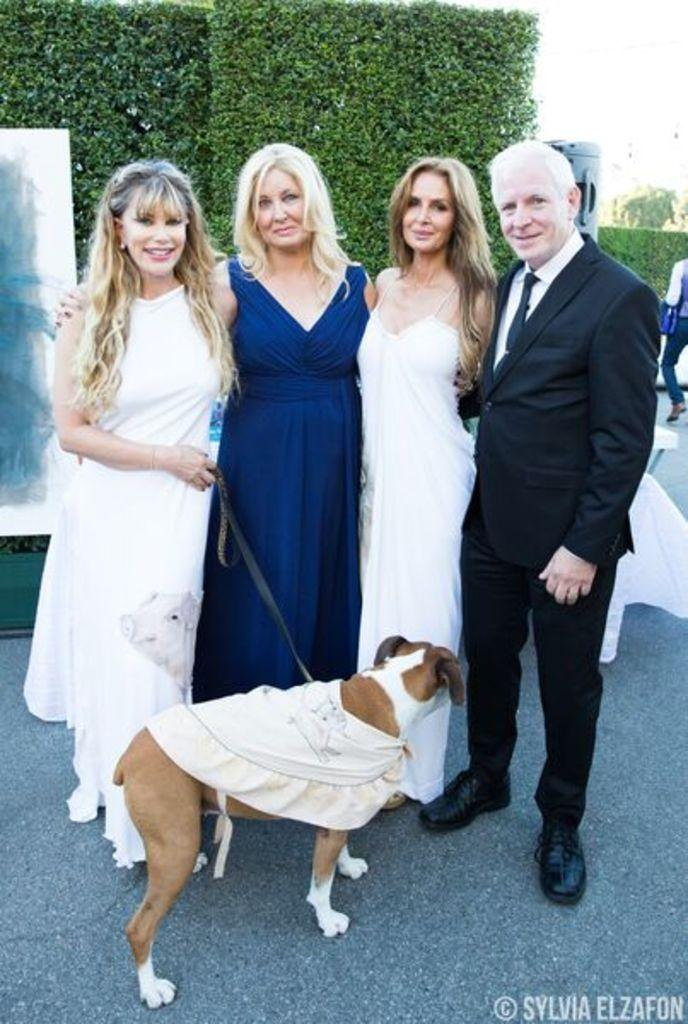How many people are in the foreground of the picture? There are four people in the foreground of the picture. What other living creature is present in the foreground of the picture? There is a dog in the foreground of the picture. What type of surface can be seen in the foreground of the picture? There is a road in the foreground of the picture. What can be seen in the background of the picture? There are plants and sky visible in the background of the picture. What is the attire of one of the men in the picture? One of the men is wearing a black suit. What type of offer is the dog making to the visitors in the picture? There are no visitors present in the image, and the dog is not making any offers. How many stitches are visible on the man's suit in the picture? The man's suit is not described in terms of stitches, and there is no mention of stitches in the image. 